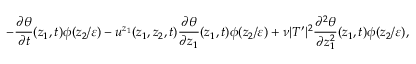<formula> <loc_0><loc_0><loc_500><loc_500>- \frac { \partial \theta } { \partial t } ( z _ { 1 } , t ) \phi ( z _ { 2 } / \varepsilon ) - u ^ { z _ { 1 } } ( z _ { 1 } , z _ { 2 } , t ) \frac { \partial \theta } { \partial z _ { 1 } } ( z _ { 1 } , t ) \phi ( z _ { 2 } / \varepsilon ) + \nu | T ^ { \prime } | ^ { 2 } \frac { \partial ^ { 2 } \theta } { \partial z _ { 1 } ^ { 2 } } ( z _ { 1 } , t ) \phi ( z _ { 2 } / \varepsilon ) ,</formula> 